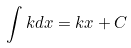<formula> <loc_0><loc_0><loc_500><loc_500>\int k d x = k x + C</formula> 